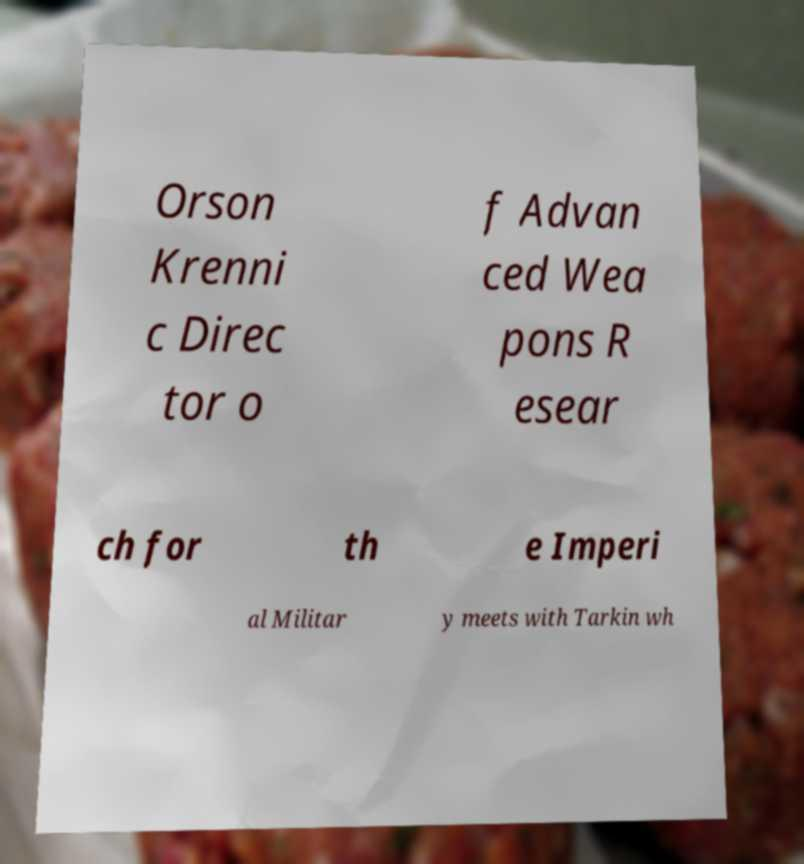Please read and relay the text visible in this image. What does it say? Orson Krenni c Direc tor o f Advan ced Wea pons R esear ch for th e Imperi al Militar y meets with Tarkin wh 